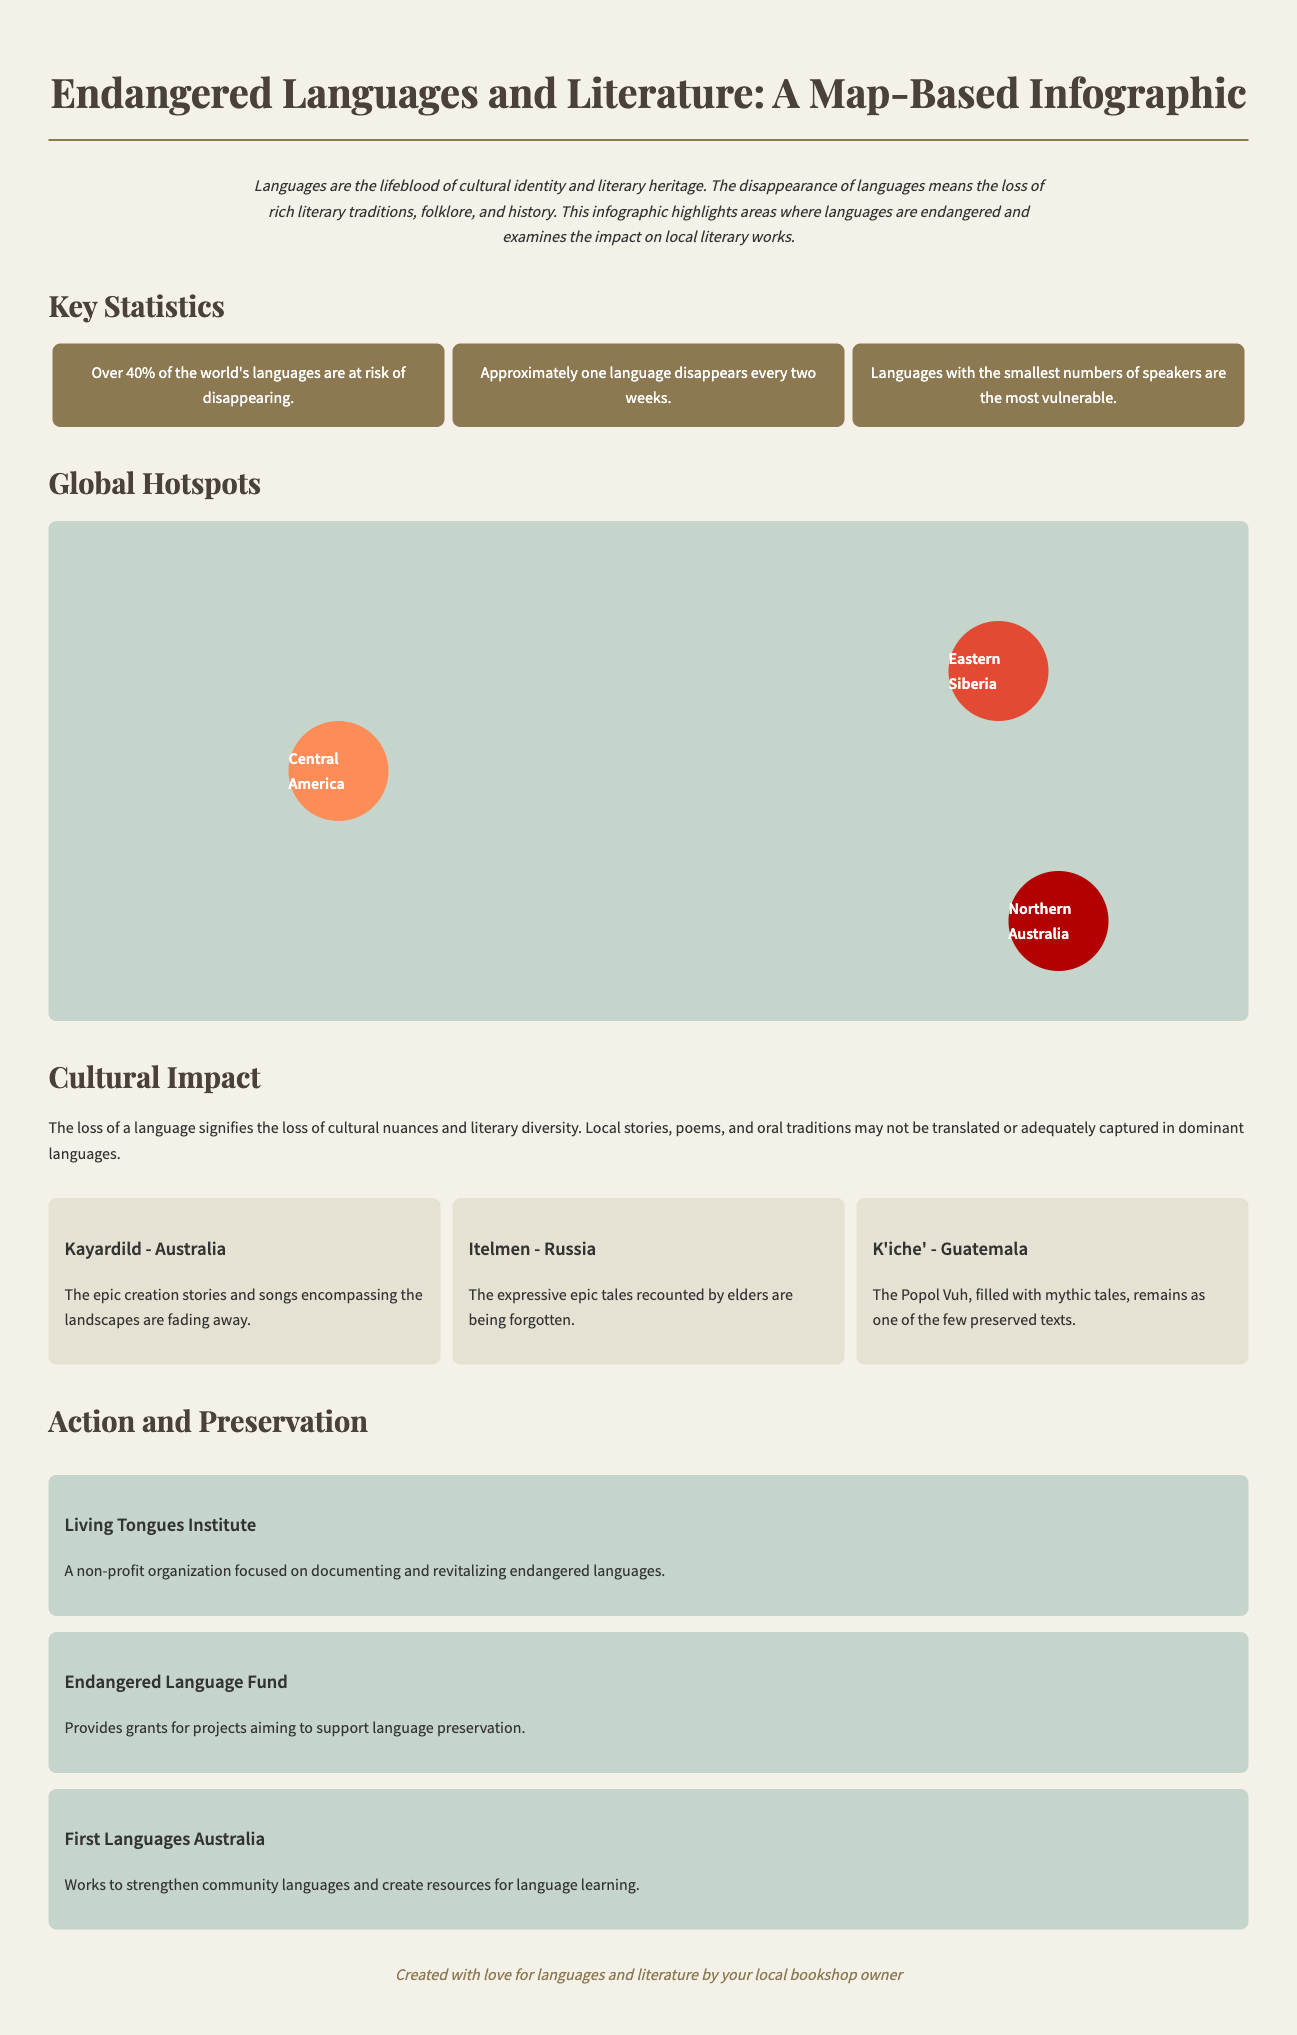What is the title of the infographic? The title is displayed prominently at the top of the infographic, indicating the main theme.
Answer: Endangered Languages and Literature: A Map-Based Infographic How many languages are mentioned for Northern Australia? The document lists specific languages for each region; Northern Australia has two mentioned.
Answer: 2 What cultural symbol is associated with Eastern Siberia? The document includes specific cultural symbols linked to each region; Eastern Siberia has one mentioned.
Answer: Reindeer What percentage of the world's languages are at risk of disappearing? The key statistics section outlines the percentage of languages at risk.
Answer: Over 40% What is the main impact on literature for Central America? The impact is described specifically for Central America regarding literature and traditions.
Answer: Indigenous stories and pre-Columbian texts are under threat What organization focuses on documenting endangered languages? The action and preservation section lists organizations dedicated to language preservation and revitalization.
Answer: Living Tongues Institute Which few preserved texts are mentioned for K'iche'? The literature impact section describes specific texts that remain preserved for K'iche'.
Answer: Popol Vuh What is a key statistic about the frequency of language disappearance? One of the key statistics indicates the rate at which languages are disappearing.
Answer: Approximately one language disappears every two weeks 